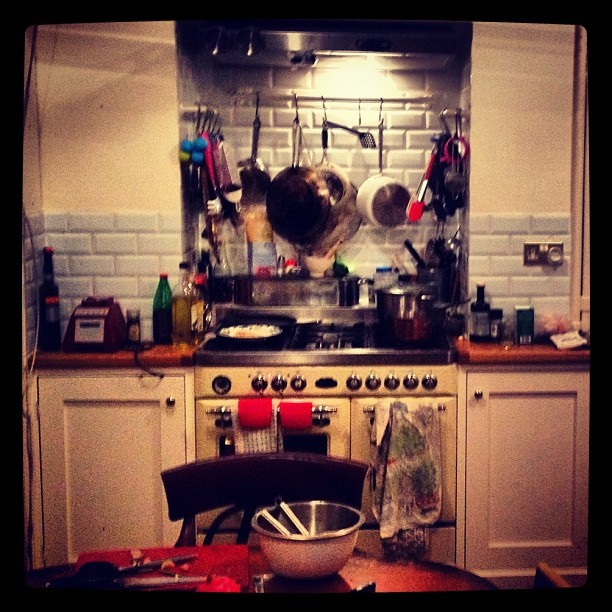Describe the objects in this image and their specific colors. I can see oven in black, tan, brown, and maroon tones, dining table in black, maroon, and brown tones, chair in black, maroon, purple, and brown tones, bowl in black, maroon, and brown tones, and bottle in black, maroon, and purple tones in this image. 